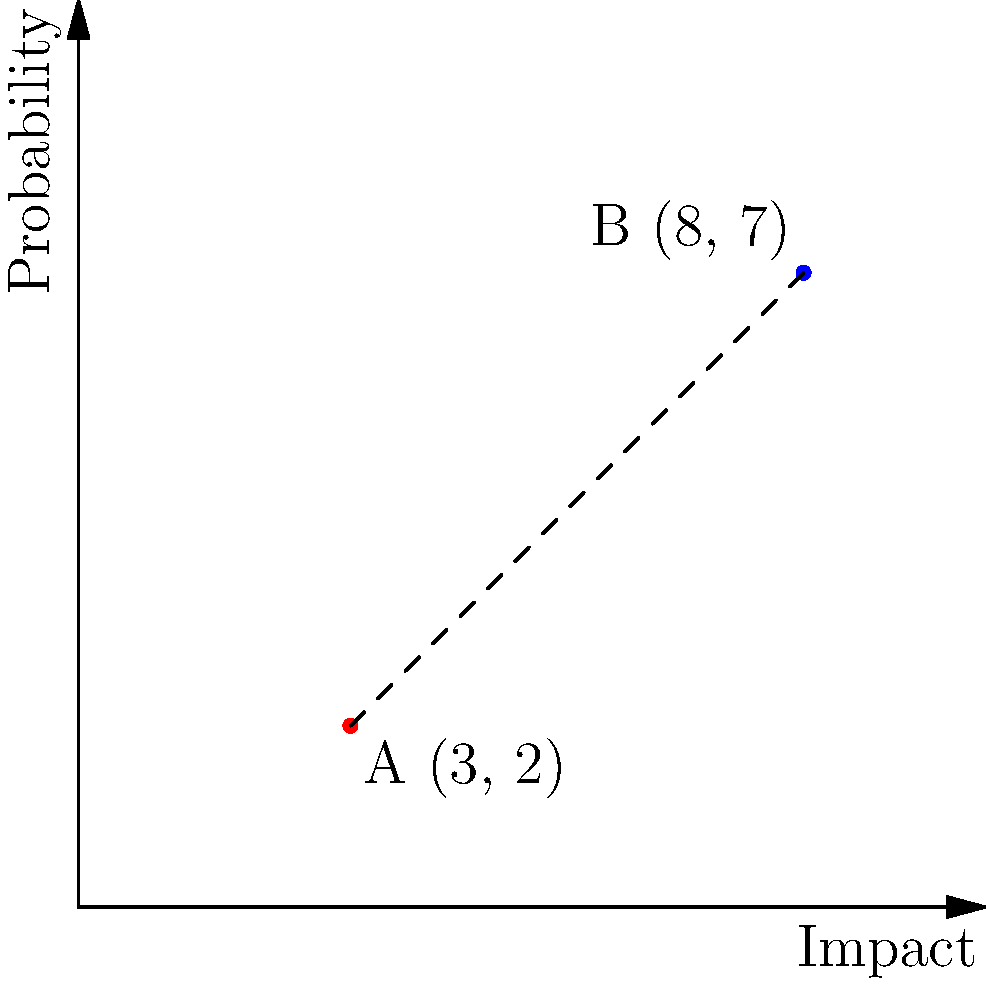In a financial risk assessment model, two potential risks are plotted on a coordinate plane where the x-axis represents the impact and the y-axis represents the probability. Risk A is located at (3, 2) and Risk B is at (8, 7). Calculate the distance between these two risks to determine their relative proximity in the risk landscape. Round your answer to two decimal places. To calculate the distance between two points on a coordinate plane, we use the distance formula, which is derived from the Pythagorean theorem:

$$d = \sqrt{(x_2 - x_1)^2 + (y_2 - y_1)^2}$$

Where:
$(x_1, y_1)$ are the coordinates of the first point (Risk A)
$(x_2, y_2)$ are the coordinates of the second point (Risk B)

Let's plug in our values:
$(x_1, y_1) = (3, 2)$ for Risk A
$(x_2, y_2) = (8, 7)$ for Risk B

Now, let's calculate:

1) First, find the differences:
   $x_2 - x_1 = 8 - 3 = 5$
   $y_2 - y_1 = 7 - 2 = 5$

2) Square these differences:
   $(x_2 - x_1)^2 = 5^2 = 25$
   $(y_2 - y_1)^2 = 5^2 = 25$

3) Sum the squared differences:
   $25 + 25 = 50$

4) Take the square root:
   $d = \sqrt{50}$

5) Simplify:
   $d = 5\sqrt{2} \approx 7.07$

6) Round to two decimal places:
   $d \approx 7.07$

Therefore, the distance between Risk A and Risk B is approximately 7.07 units in the risk landscape.
Answer: 7.07 units 